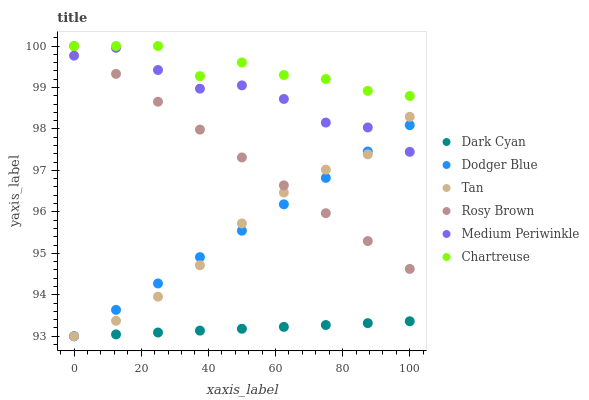Does Dark Cyan have the minimum area under the curve?
Answer yes or no. Yes. Does Chartreuse have the maximum area under the curve?
Answer yes or no. Yes. Does Medium Periwinkle have the minimum area under the curve?
Answer yes or no. No. Does Medium Periwinkle have the maximum area under the curve?
Answer yes or no. No. Is Dark Cyan the smoothest?
Answer yes or no. Yes. Is Chartreuse the roughest?
Answer yes or no. Yes. Is Medium Periwinkle the smoothest?
Answer yes or no. No. Is Medium Periwinkle the roughest?
Answer yes or no. No. Does Dodger Blue have the lowest value?
Answer yes or no. Yes. Does Medium Periwinkle have the lowest value?
Answer yes or no. No. Does Chartreuse have the highest value?
Answer yes or no. Yes. Does Medium Periwinkle have the highest value?
Answer yes or no. No. Is Tan less than Chartreuse?
Answer yes or no. Yes. Is Chartreuse greater than Tan?
Answer yes or no. Yes. Does Rosy Brown intersect Medium Periwinkle?
Answer yes or no. Yes. Is Rosy Brown less than Medium Periwinkle?
Answer yes or no. No. Is Rosy Brown greater than Medium Periwinkle?
Answer yes or no. No. Does Tan intersect Chartreuse?
Answer yes or no. No. 